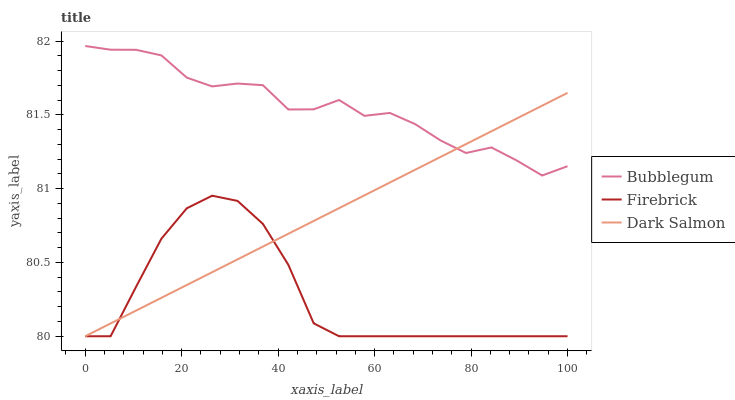Does Firebrick have the minimum area under the curve?
Answer yes or no. Yes. Does Bubblegum have the maximum area under the curve?
Answer yes or no. Yes. Does Dark Salmon have the minimum area under the curve?
Answer yes or no. No. Does Dark Salmon have the maximum area under the curve?
Answer yes or no. No. Is Dark Salmon the smoothest?
Answer yes or no. Yes. Is Bubblegum the roughest?
Answer yes or no. Yes. Is Bubblegum the smoothest?
Answer yes or no. No. Is Dark Salmon the roughest?
Answer yes or no. No. Does Firebrick have the lowest value?
Answer yes or no. Yes. Does Bubblegum have the lowest value?
Answer yes or no. No. Does Bubblegum have the highest value?
Answer yes or no. Yes. Does Dark Salmon have the highest value?
Answer yes or no. No. Is Firebrick less than Bubblegum?
Answer yes or no. Yes. Is Bubblegum greater than Firebrick?
Answer yes or no. Yes. Does Dark Salmon intersect Bubblegum?
Answer yes or no. Yes. Is Dark Salmon less than Bubblegum?
Answer yes or no. No. Is Dark Salmon greater than Bubblegum?
Answer yes or no. No. Does Firebrick intersect Bubblegum?
Answer yes or no. No. 